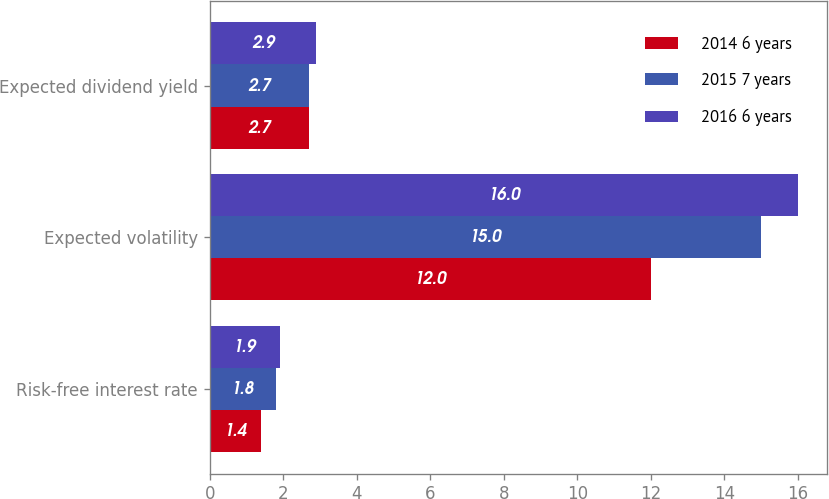<chart> <loc_0><loc_0><loc_500><loc_500><stacked_bar_chart><ecel><fcel>Risk-free interest rate<fcel>Expected volatility<fcel>Expected dividend yield<nl><fcel>2014 6 years<fcel>1.4<fcel>12<fcel>2.7<nl><fcel>2015 7 years<fcel>1.8<fcel>15<fcel>2.7<nl><fcel>2016 6 years<fcel>1.9<fcel>16<fcel>2.9<nl></chart> 